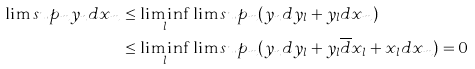Convert formula to latex. <formula><loc_0><loc_0><loc_500><loc_500>\lim s u p _ { m } y _ { n } d x _ { m } & \leq \liminf _ { l } \lim s u p _ { m } ( y _ { n } d y _ { l } + y _ { l } d x _ { m } ) \\ & \leq \liminf _ { l } \lim s u p _ { m } ( y _ { n } d y _ { l } + y _ { l } \overline { d } x _ { l } + x _ { l } d x _ { m } ) = 0</formula> 